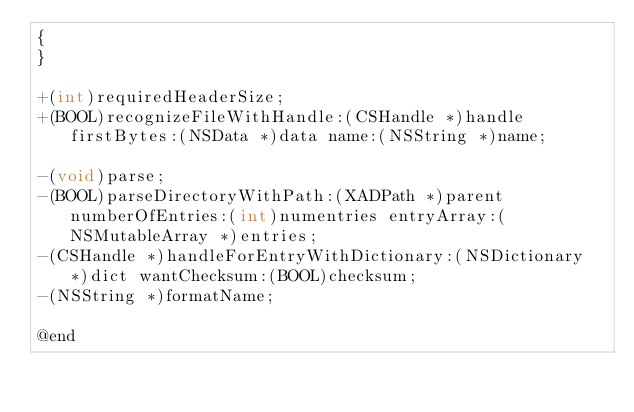<code> <loc_0><loc_0><loc_500><loc_500><_C_>{
}

+(int)requiredHeaderSize;
+(BOOL)recognizeFileWithHandle:(CSHandle *)handle firstBytes:(NSData *)data name:(NSString *)name;

-(void)parse;
-(BOOL)parseDirectoryWithPath:(XADPath *)parent numberOfEntries:(int)numentries entryArray:(NSMutableArray *)entries;
-(CSHandle *)handleForEntryWithDictionary:(NSDictionary *)dict wantChecksum:(BOOL)checksum;
-(NSString *)formatName;

@end
</code> 